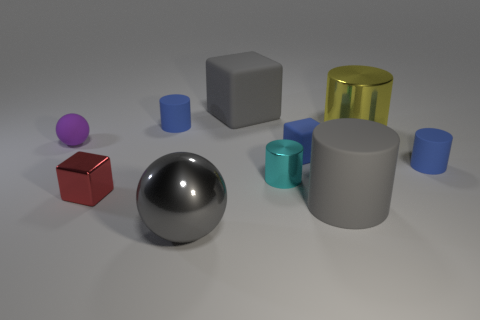There is a tiny matte ball to the left of the large gray shiny sphere; is it the same color as the big rubber cylinder?
Offer a terse response. No. What is the size of the ball that is in front of the small red object?
Provide a short and direct response. Large. The big gray rubber thing that is in front of the small matte cylinder that is behind the small rubber ball is what shape?
Your answer should be compact. Cylinder. There is a big rubber object that is the same shape as the small cyan metal thing; what is its color?
Your response must be concise. Gray. There is a sphere that is behind the metal ball; is it the same size as the big metallic cylinder?
Your answer should be compact. No. What is the shape of the shiny thing that is the same color as the big block?
Provide a succinct answer. Sphere. How many other tiny balls are the same material as the purple ball?
Your response must be concise. 0. There is a thing that is behind the blue matte object that is to the left of the big gray shiny ball that is on the left side of the small cyan cylinder; what is it made of?
Provide a short and direct response. Rubber. The metal cylinder that is left of the yellow metallic cylinder behind the tiny red metallic object is what color?
Offer a terse response. Cyan. There is a matte object that is the same size as the gray rubber cube; what color is it?
Offer a very short reply. Gray. 